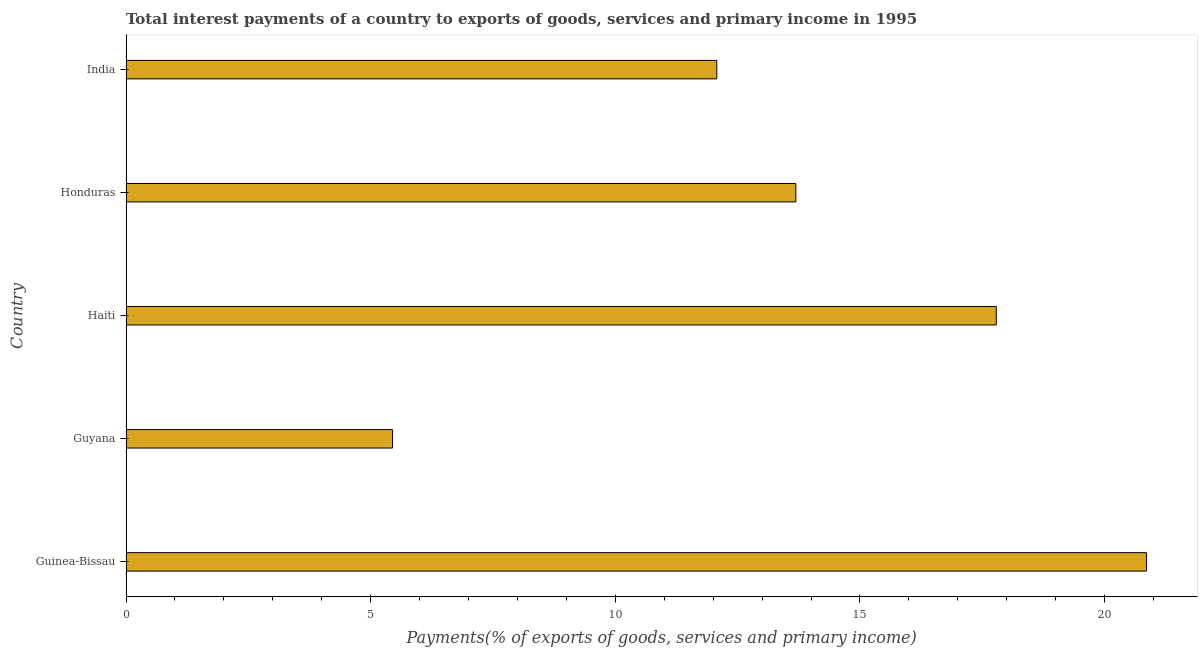Does the graph contain any zero values?
Provide a short and direct response. No. Does the graph contain grids?
Give a very brief answer. No. What is the title of the graph?
Offer a very short reply. Total interest payments of a country to exports of goods, services and primary income in 1995. What is the label or title of the X-axis?
Your answer should be compact. Payments(% of exports of goods, services and primary income). What is the total interest payments on external debt in Guinea-Bissau?
Keep it short and to the point. 20.86. Across all countries, what is the maximum total interest payments on external debt?
Your answer should be very brief. 20.86. Across all countries, what is the minimum total interest payments on external debt?
Offer a very short reply. 5.45. In which country was the total interest payments on external debt maximum?
Your response must be concise. Guinea-Bissau. In which country was the total interest payments on external debt minimum?
Ensure brevity in your answer.  Guyana. What is the sum of the total interest payments on external debt?
Provide a succinct answer. 69.85. What is the difference between the total interest payments on external debt in Guinea-Bissau and Haiti?
Provide a succinct answer. 3.07. What is the average total interest payments on external debt per country?
Offer a terse response. 13.97. What is the median total interest payments on external debt?
Offer a terse response. 13.69. What is the ratio of the total interest payments on external debt in Haiti to that in India?
Keep it short and to the point. 1.47. Is the total interest payments on external debt in Guinea-Bissau less than that in India?
Offer a terse response. No. What is the difference between the highest and the second highest total interest payments on external debt?
Make the answer very short. 3.07. What is the difference between the highest and the lowest total interest payments on external debt?
Your response must be concise. 15.41. In how many countries, is the total interest payments on external debt greater than the average total interest payments on external debt taken over all countries?
Keep it short and to the point. 2. Are all the bars in the graph horizontal?
Ensure brevity in your answer.  Yes. How many countries are there in the graph?
Offer a very short reply. 5. What is the Payments(% of exports of goods, services and primary income) of Guinea-Bissau?
Your response must be concise. 20.86. What is the Payments(% of exports of goods, services and primary income) of Guyana?
Your response must be concise. 5.45. What is the Payments(% of exports of goods, services and primary income) in Haiti?
Offer a very short reply. 17.79. What is the Payments(% of exports of goods, services and primary income) in Honduras?
Your answer should be very brief. 13.69. What is the Payments(% of exports of goods, services and primary income) of India?
Provide a short and direct response. 12.07. What is the difference between the Payments(% of exports of goods, services and primary income) in Guinea-Bissau and Guyana?
Your answer should be compact. 15.41. What is the difference between the Payments(% of exports of goods, services and primary income) in Guinea-Bissau and Haiti?
Offer a terse response. 3.07. What is the difference between the Payments(% of exports of goods, services and primary income) in Guinea-Bissau and Honduras?
Ensure brevity in your answer.  7.17. What is the difference between the Payments(% of exports of goods, services and primary income) in Guinea-Bissau and India?
Offer a very short reply. 8.78. What is the difference between the Payments(% of exports of goods, services and primary income) in Guyana and Haiti?
Ensure brevity in your answer.  -12.34. What is the difference between the Payments(% of exports of goods, services and primary income) in Guyana and Honduras?
Offer a very short reply. -8.24. What is the difference between the Payments(% of exports of goods, services and primary income) in Guyana and India?
Give a very brief answer. -6.63. What is the difference between the Payments(% of exports of goods, services and primary income) in Haiti and Honduras?
Provide a succinct answer. 4.1. What is the difference between the Payments(% of exports of goods, services and primary income) in Haiti and India?
Offer a very short reply. 5.71. What is the difference between the Payments(% of exports of goods, services and primary income) in Honduras and India?
Your answer should be very brief. 1.62. What is the ratio of the Payments(% of exports of goods, services and primary income) in Guinea-Bissau to that in Guyana?
Provide a succinct answer. 3.83. What is the ratio of the Payments(% of exports of goods, services and primary income) in Guinea-Bissau to that in Haiti?
Offer a terse response. 1.17. What is the ratio of the Payments(% of exports of goods, services and primary income) in Guinea-Bissau to that in Honduras?
Give a very brief answer. 1.52. What is the ratio of the Payments(% of exports of goods, services and primary income) in Guinea-Bissau to that in India?
Offer a very short reply. 1.73. What is the ratio of the Payments(% of exports of goods, services and primary income) in Guyana to that in Haiti?
Give a very brief answer. 0.31. What is the ratio of the Payments(% of exports of goods, services and primary income) in Guyana to that in Honduras?
Your answer should be very brief. 0.4. What is the ratio of the Payments(% of exports of goods, services and primary income) in Guyana to that in India?
Your answer should be very brief. 0.45. What is the ratio of the Payments(% of exports of goods, services and primary income) in Haiti to that in Honduras?
Provide a succinct answer. 1.3. What is the ratio of the Payments(% of exports of goods, services and primary income) in Haiti to that in India?
Give a very brief answer. 1.47. What is the ratio of the Payments(% of exports of goods, services and primary income) in Honduras to that in India?
Give a very brief answer. 1.13. 